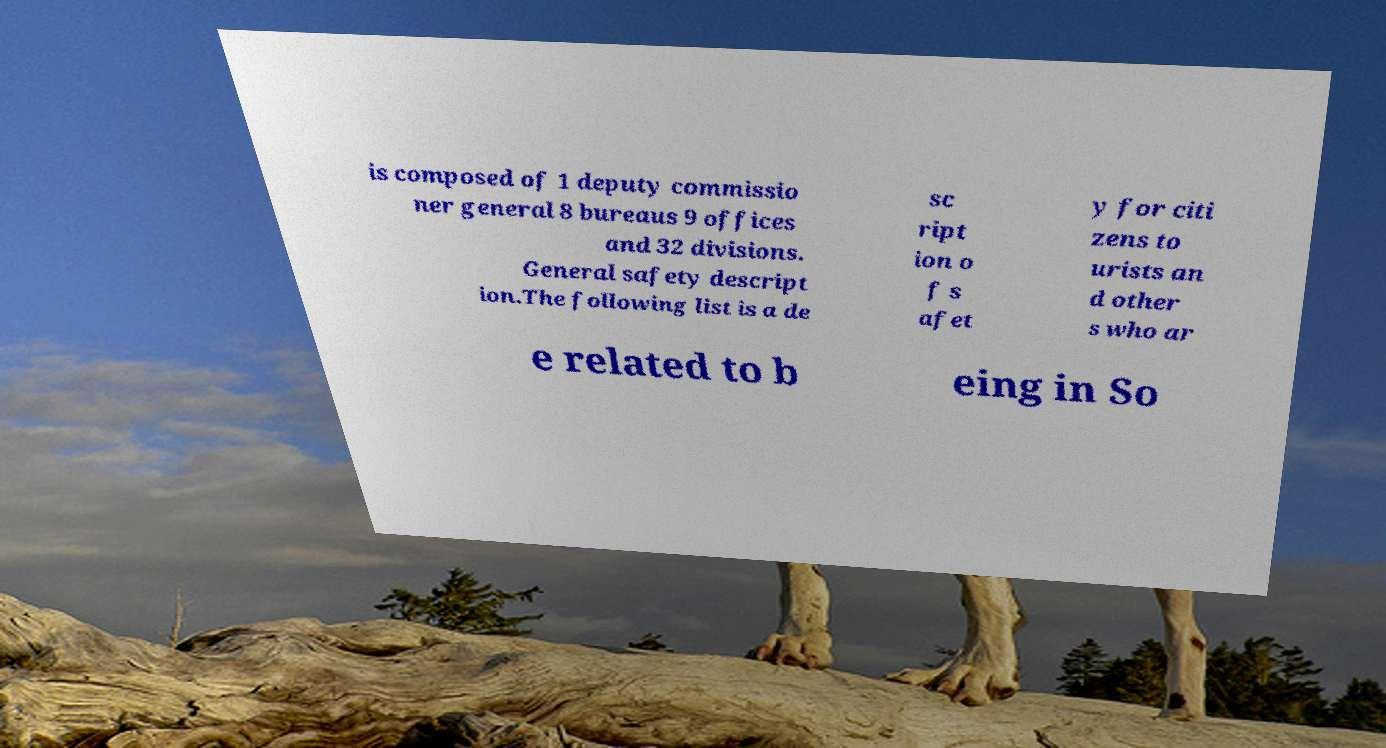I need the written content from this picture converted into text. Can you do that? is composed of 1 deputy commissio ner general 8 bureaus 9 offices and 32 divisions. General safety descript ion.The following list is a de sc ript ion o f s afet y for citi zens to urists an d other s who ar e related to b eing in So 